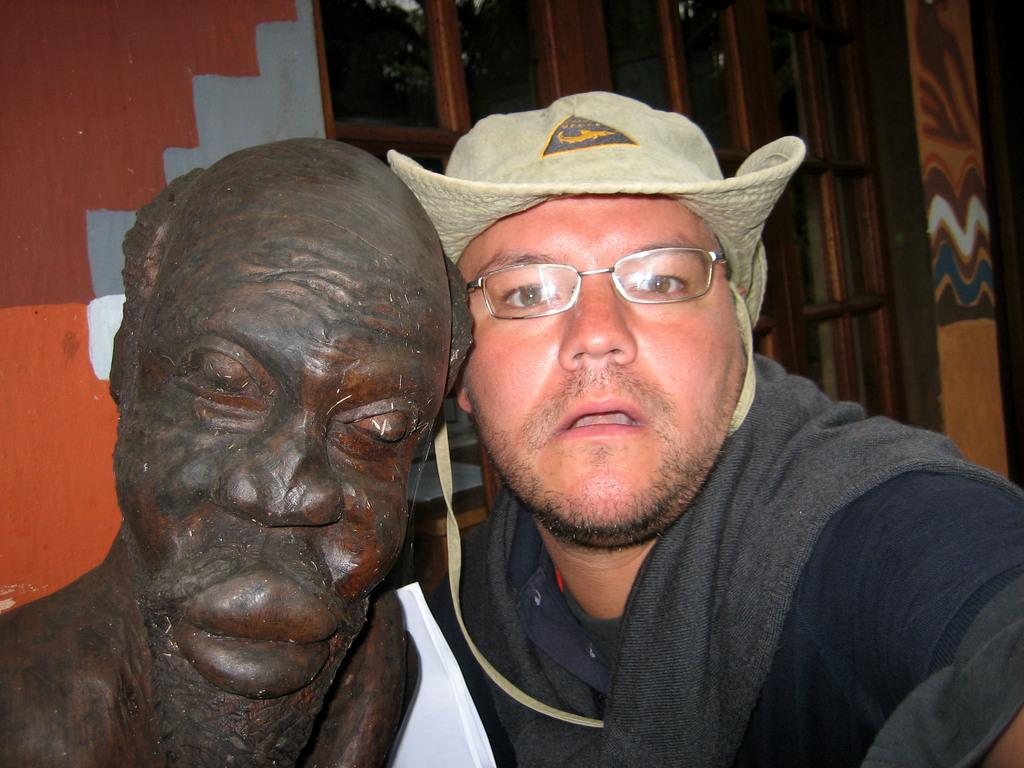What is the main subject in the center of the image? There is a statue and persons in the center of the image. Can you describe the statue in the image? Unfortunately, the facts provided do not give any details about the statue. What can be seen in the background of the image? There is a window and a wall in the background of the image. What type of ink is being used by the persons in the image? There is no indication in the image that the persons are using ink or engaging in any activity that would require ink. 